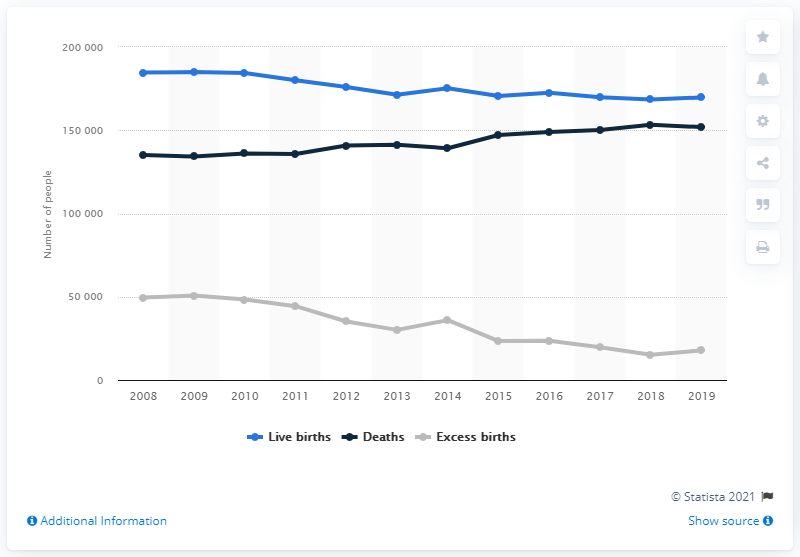Indicate a few pertinent items in this graphic. Since 2008, the number of live births in the Netherlands has been decreasing. 